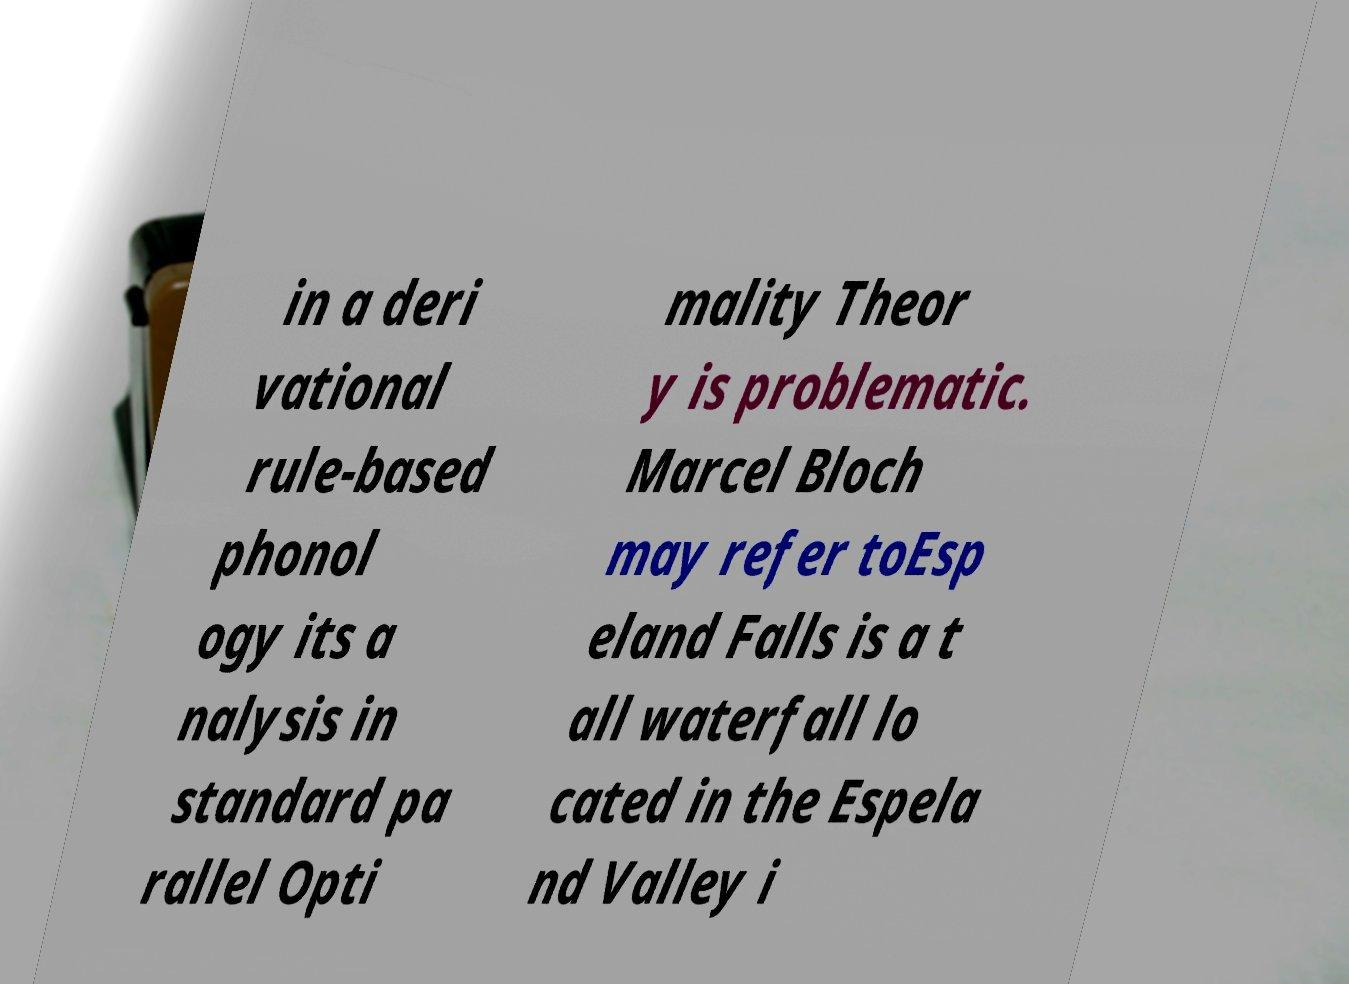Please read and relay the text visible in this image. What does it say? in a deri vational rule-based phonol ogy its a nalysis in standard pa rallel Opti mality Theor y is problematic. Marcel Bloch may refer toEsp eland Falls is a t all waterfall lo cated in the Espela nd Valley i 